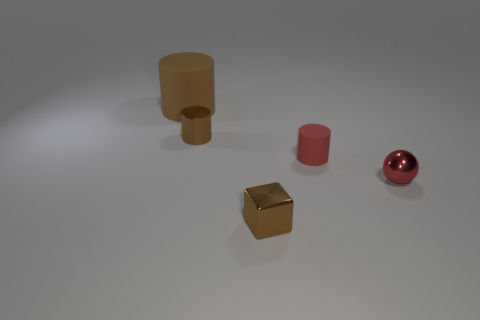What shape is the shiny object that is the same color as the tiny matte cylinder?
Make the answer very short. Sphere. The small thing on the left side of the cube has what shape?
Offer a very short reply. Cylinder. Do the matte thing that is behind the small rubber object and the metallic object left of the small metal block have the same color?
Your answer should be very brief. Yes. There is a rubber cylinder that is the same color as the tiny block; what is its size?
Keep it short and to the point. Large. Is there a tiny yellow shiny thing?
Make the answer very short. No. There is a small metal thing that is right of the brown shiny object in front of the tiny brown metal thing to the left of the tiny brown block; what shape is it?
Your response must be concise. Sphere. There is a ball; what number of small red objects are left of it?
Make the answer very short. 1. Do the large object that is behind the metallic ball and the small red ball have the same material?
Provide a short and direct response. No. What number of other things are there of the same shape as the brown rubber thing?
Offer a terse response. 2. There is a tiny red cylinder that is right of the small thing that is left of the tiny metal cube; what number of red metal objects are behind it?
Offer a terse response. 0. 